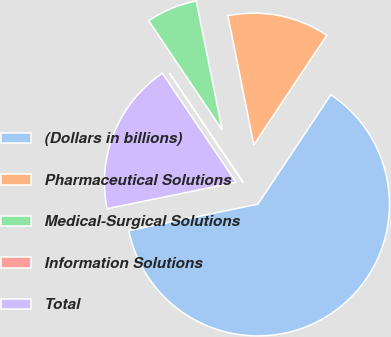Convert chart to OTSL. <chart><loc_0><loc_0><loc_500><loc_500><pie_chart><fcel>(Dollars in billions)<fcel>Pharmaceutical Solutions<fcel>Medical-Surgical Solutions<fcel>Information Solutions<fcel>Total<nl><fcel>62.43%<fcel>12.51%<fcel>6.27%<fcel>0.03%<fcel>18.75%<nl></chart> 